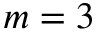<formula> <loc_0><loc_0><loc_500><loc_500>m = 3</formula> 